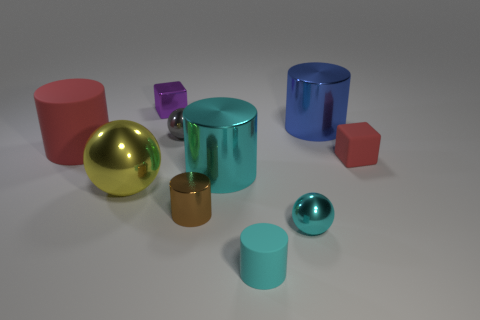Subtract 2 cylinders. How many cylinders are left? 3 Subtract all purple cylinders. Subtract all gray balls. How many cylinders are left? 5 Subtract all balls. How many objects are left? 7 Subtract all red blocks. Subtract all purple matte objects. How many objects are left? 9 Add 6 gray metal objects. How many gray metal objects are left? 7 Add 2 cylinders. How many cylinders exist? 7 Subtract 0 blue balls. How many objects are left? 10 